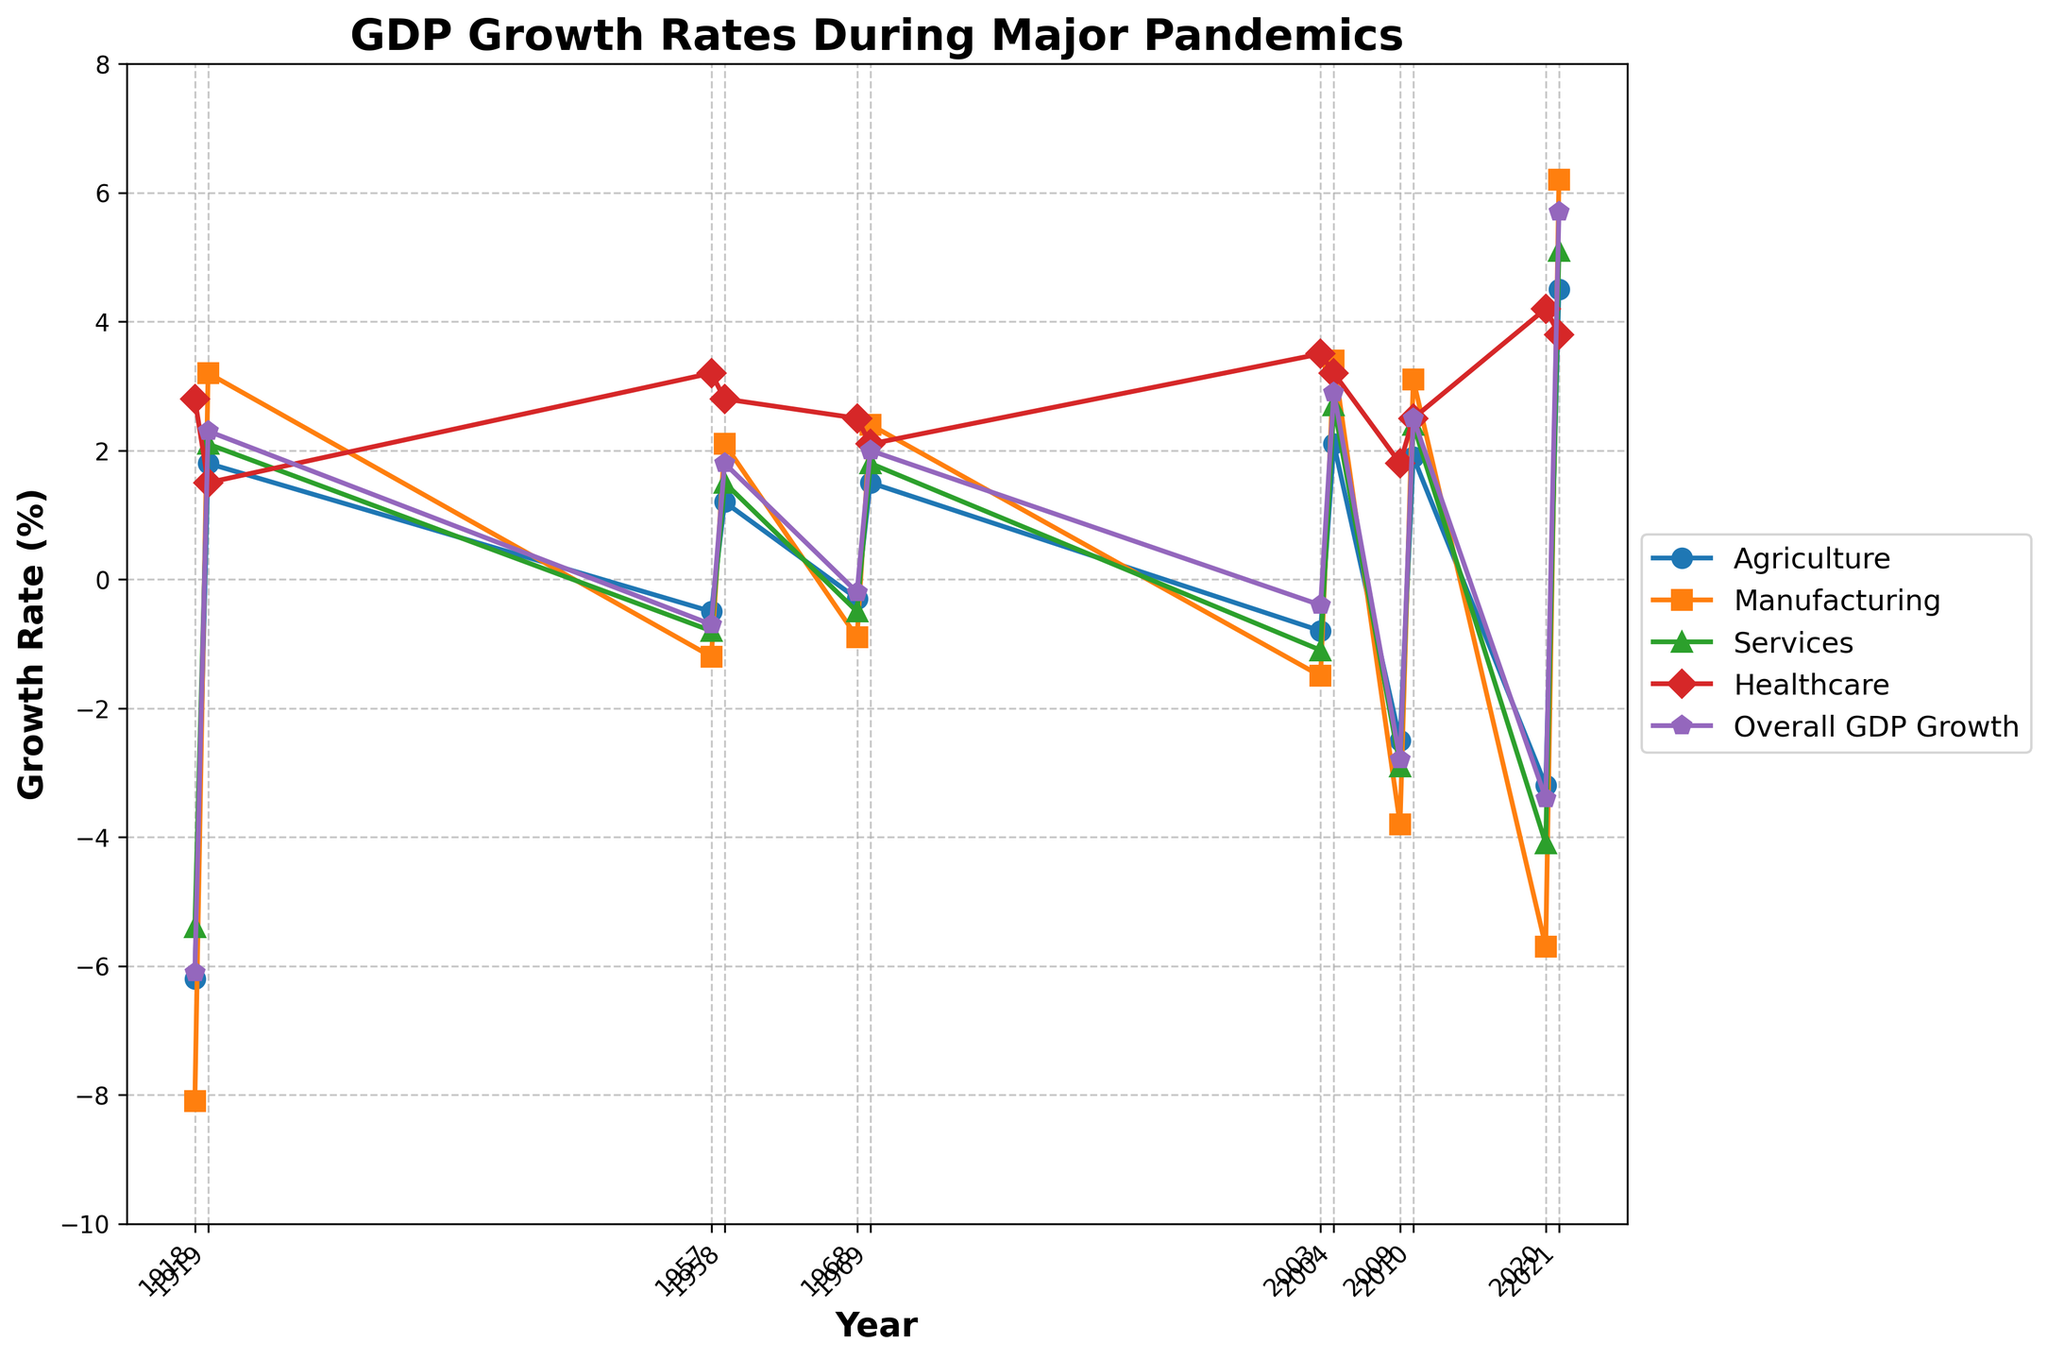Which sector had the highest growth rate in 2021? Based on the figure, in 2021, the highest growth rate is represented by the Healthcare sector's line, which is indicated by the data point that reaches the highest position among all sectors.
Answer: Healthcare How did the Manufacturing sector's growth rate change from 2009 to 2010? To determine the change, we look at the positions of the data points for Manufacturing in 2009 and 2010. In 2009, Manufacturing was at -3.8%, and in 2010, it was at 3.1%. The change is 3.1 - (-3.8) = 6.9%.
Answer: 6.9% What was the overall GDP growth rate during the 1957 pandemic? Referring to the figure, the data point for Overall GDP Growth in 1957 is positioned at -0.7%.
Answer: -0.7% Compare the growth rate of Services to Healthcare in 1968. Which was higher? From the visual information, the Services growth rate was -0.5%, while Healthcare was 2.5%. Since 2.5% is greater than -0.5%, Healthcare had a higher growth rate in 1968.
Answer: Healthcare Which year saw the largest negative growth in Agriculture? By identifying the lowest data point in the Agriculture line, the year with the largest negative growth is found at 1918 with -6.2%.
Answer: 1918 What was the difference between the Healthcare sector's growth rate and the Overall GDP Growth rate in 2003? Referring to 2003, Healthcare's growth rate is 3.5%, and Overall GDP Growth is -0.4%. The difference is 3.5 - (-0.4) = 3.9%.
Answer: 3.9% Which sector experienced a positive growth rate during the 2020 pandemic? In 2020, we need to identify if there is any sector's data point above 0. Healthcare is the only sector with a data point at 4.2%, indicating positive growth.
Answer: Healthcare Calculate the average growth rate of the Manufacturing sector for the years 1918, 1957, and 2020. We sum the growth rates for these years (1918: -8.1%, 1957: -1.2%, 2020: -5.7%) and then divide by 3. The calculation is (-8.1 + (-1.2) + (-5.7)) / 3 = -5.0%.
Answer: -5.0% In terms of overall GDP growth, which year bounced back more significantly after a pandemic: 1919 or 1958? Comparing 1919 and 1958 for Overall GDP Growth, in 1919 the growth is 2.3%, and in 1958 it is 1.8%. Since 2.3% is greater than 1.8%, the year 1919 had a more significant bounce back.
Answer: 1919 What is the trend in growth rates for the Services sector from 2009 to 2010? By examining the positioning of the data points, the Services sector moved from -2.9% in 2009 to 2.4% in 2010. The observed trend is an increase in the growth rate.
Answer: Increase 